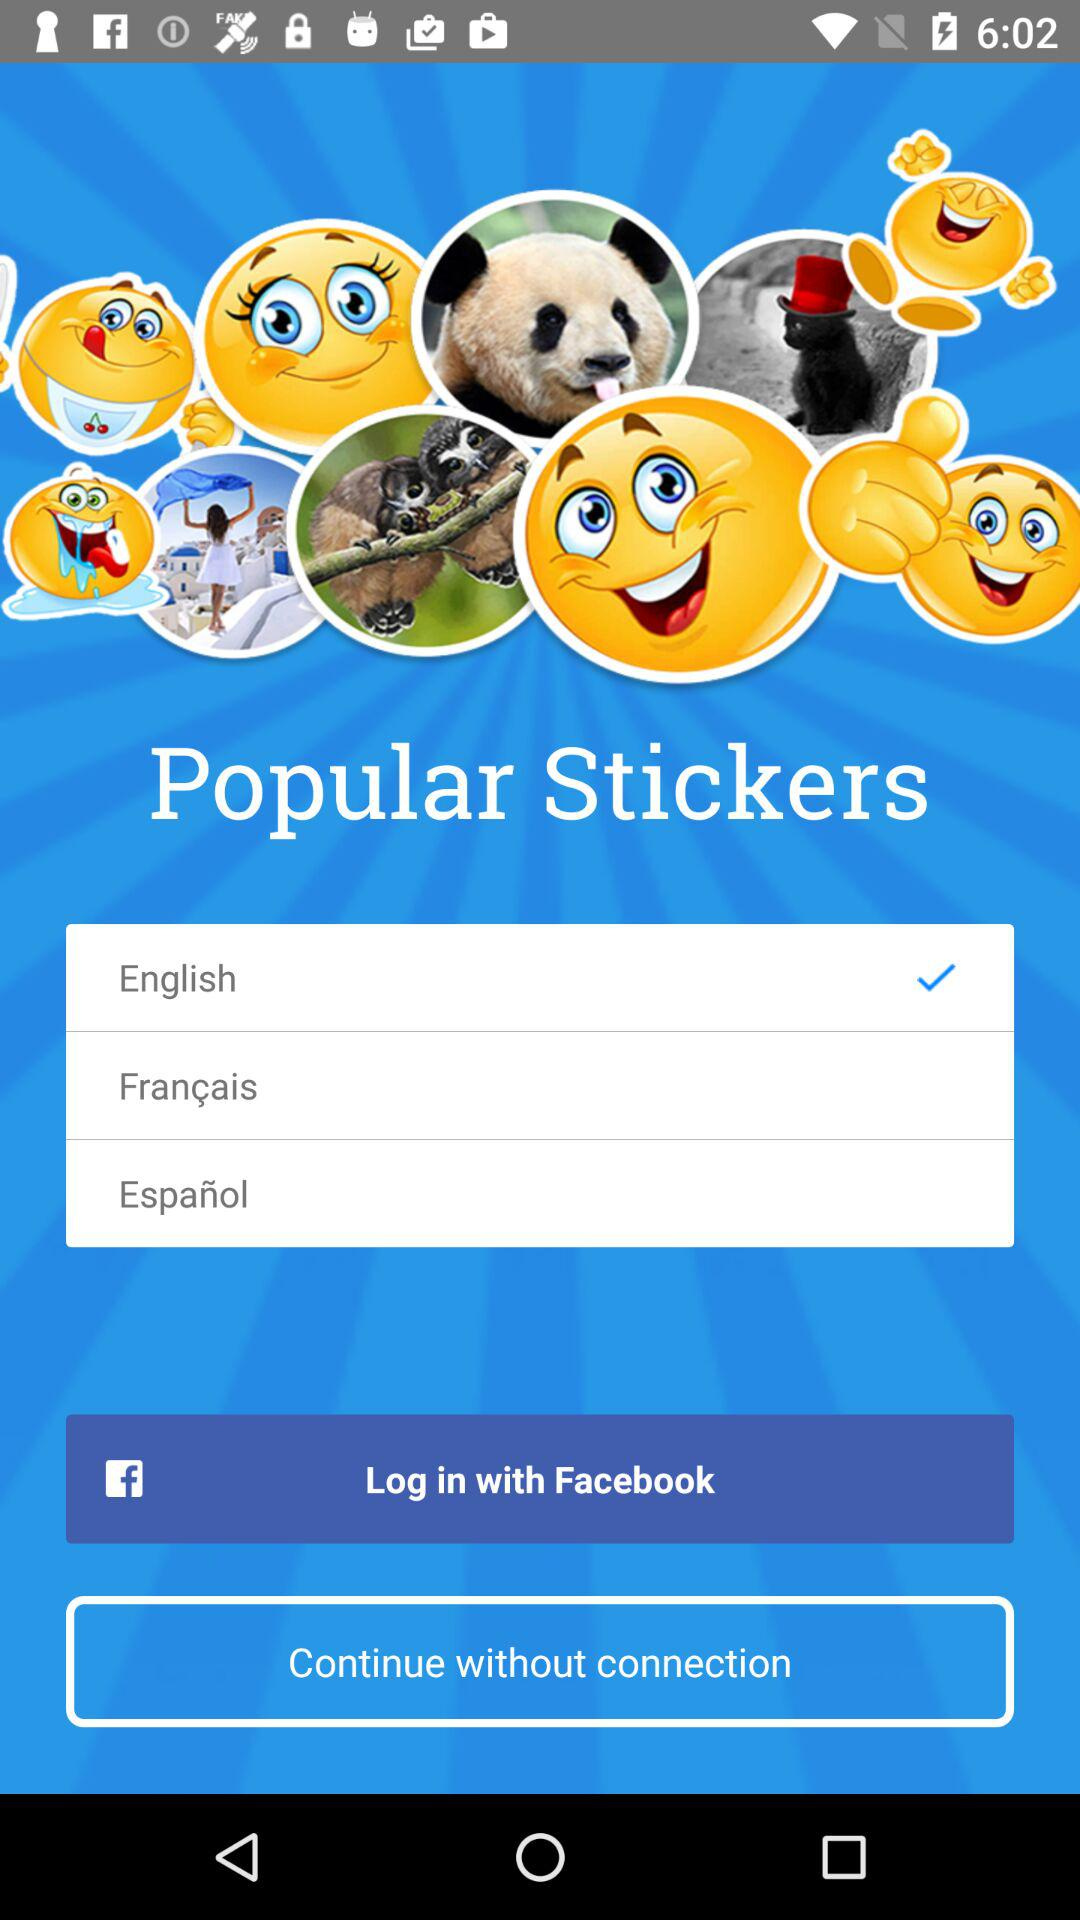Which language is selected? The selected language is English. 